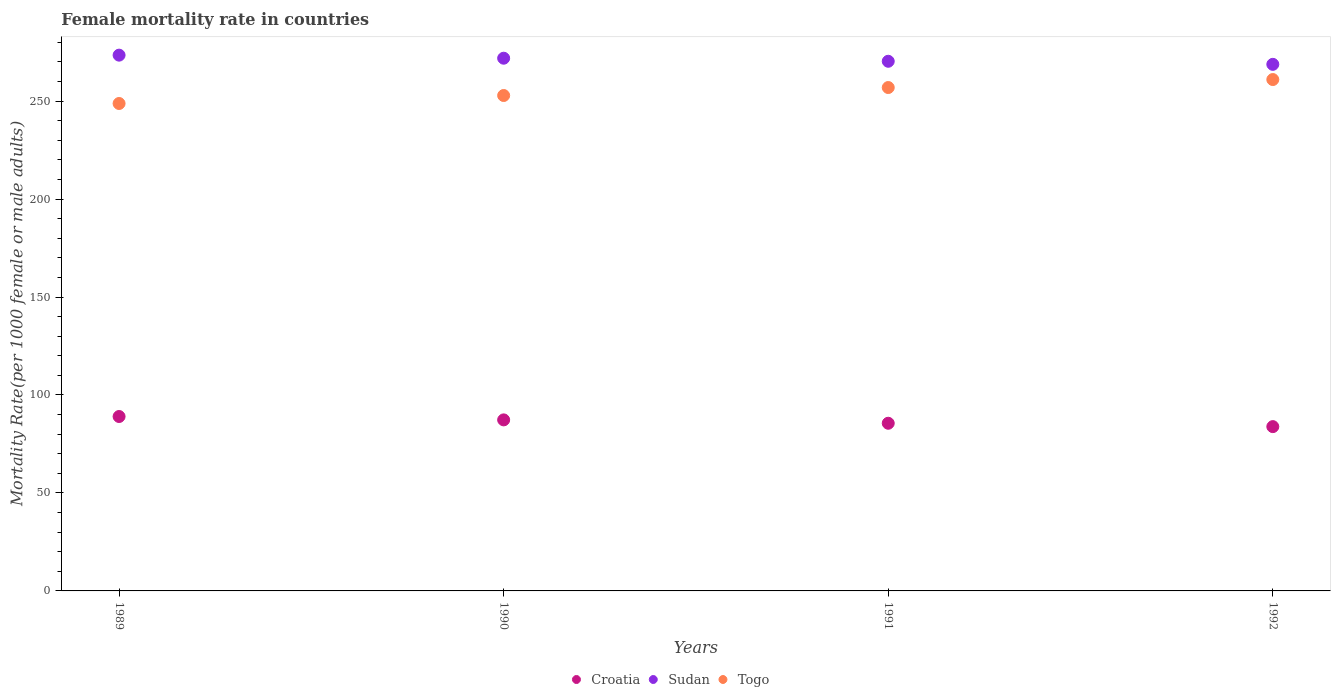How many different coloured dotlines are there?
Provide a short and direct response. 3. Is the number of dotlines equal to the number of legend labels?
Provide a succinct answer. Yes. What is the female mortality rate in Croatia in 1992?
Provide a short and direct response. 83.86. Across all years, what is the maximum female mortality rate in Togo?
Ensure brevity in your answer.  261. Across all years, what is the minimum female mortality rate in Togo?
Make the answer very short. 248.78. In which year was the female mortality rate in Togo maximum?
Your answer should be compact. 1992. In which year was the female mortality rate in Togo minimum?
Give a very brief answer. 1989. What is the total female mortality rate in Togo in the graph?
Make the answer very short. 1019.56. What is the difference between the female mortality rate in Sudan in 1991 and that in 1992?
Keep it short and to the point. 1.56. What is the difference between the female mortality rate in Sudan in 1989 and the female mortality rate in Croatia in 1990?
Provide a succinct answer. 186.16. What is the average female mortality rate in Croatia per year?
Keep it short and to the point. 86.44. In the year 1992, what is the difference between the female mortality rate in Togo and female mortality rate in Sudan?
Provide a short and direct response. -7.76. In how many years, is the female mortality rate in Sudan greater than 150?
Your answer should be very brief. 4. What is the ratio of the female mortality rate in Sudan in 1989 to that in 1992?
Make the answer very short. 1.02. Is the difference between the female mortality rate in Togo in 1991 and 1992 greater than the difference between the female mortality rate in Sudan in 1991 and 1992?
Keep it short and to the point. No. What is the difference between the highest and the second highest female mortality rate in Croatia?
Your answer should be compact. 1.72. What is the difference between the highest and the lowest female mortality rate in Sudan?
Your response must be concise. 4.69. In how many years, is the female mortality rate in Togo greater than the average female mortality rate in Togo taken over all years?
Your answer should be very brief. 2. Does the female mortality rate in Sudan monotonically increase over the years?
Offer a terse response. No. Is the female mortality rate in Togo strictly greater than the female mortality rate in Croatia over the years?
Give a very brief answer. Yes. Is the female mortality rate in Togo strictly less than the female mortality rate in Sudan over the years?
Offer a terse response. Yes. What is the difference between two consecutive major ticks on the Y-axis?
Ensure brevity in your answer.  50. Where does the legend appear in the graph?
Your response must be concise. Bottom center. How many legend labels are there?
Your response must be concise. 3. How are the legend labels stacked?
Your answer should be very brief. Horizontal. What is the title of the graph?
Ensure brevity in your answer.  Female mortality rate in countries. What is the label or title of the X-axis?
Keep it short and to the point. Years. What is the label or title of the Y-axis?
Your response must be concise. Mortality Rate(per 1000 female or male adults). What is the Mortality Rate(per 1000 female or male adults) of Croatia in 1989?
Offer a very short reply. 89.02. What is the Mortality Rate(per 1000 female or male adults) of Sudan in 1989?
Ensure brevity in your answer.  273.45. What is the Mortality Rate(per 1000 female or male adults) in Togo in 1989?
Provide a succinct answer. 248.78. What is the Mortality Rate(per 1000 female or male adults) of Croatia in 1990?
Ensure brevity in your answer.  87.3. What is the Mortality Rate(per 1000 female or male adults) in Sudan in 1990?
Ensure brevity in your answer.  271.89. What is the Mortality Rate(per 1000 female or male adults) of Togo in 1990?
Make the answer very short. 252.85. What is the Mortality Rate(per 1000 female or male adults) in Croatia in 1991?
Your response must be concise. 85.58. What is the Mortality Rate(per 1000 female or male adults) of Sudan in 1991?
Your answer should be very brief. 270.33. What is the Mortality Rate(per 1000 female or male adults) of Togo in 1991?
Provide a short and direct response. 256.93. What is the Mortality Rate(per 1000 female or male adults) in Croatia in 1992?
Provide a short and direct response. 83.86. What is the Mortality Rate(per 1000 female or male adults) of Sudan in 1992?
Ensure brevity in your answer.  268.76. What is the Mortality Rate(per 1000 female or male adults) in Togo in 1992?
Your answer should be very brief. 261. Across all years, what is the maximum Mortality Rate(per 1000 female or male adults) of Croatia?
Offer a terse response. 89.02. Across all years, what is the maximum Mortality Rate(per 1000 female or male adults) in Sudan?
Offer a very short reply. 273.45. Across all years, what is the maximum Mortality Rate(per 1000 female or male adults) of Togo?
Ensure brevity in your answer.  261. Across all years, what is the minimum Mortality Rate(per 1000 female or male adults) of Croatia?
Your response must be concise. 83.86. Across all years, what is the minimum Mortality Rate(per 1000 female or male adults) in Sudan?
Keep it short and to the point. 268.76. Across all years, what is the minimum Mortality Rate(per 1000 female or male adults) of Togo?
Offer a terse response. 248.78. What is the total Mortality Rate(per 1000 female or male adults) of Croatia in the graph?
Offer a very short reply. 345.75. What is the total Mortality Rate(per 1000 female or male adults) in Sudan in the graph?
Give a very brief answer. 1084.44. What is the total Mortality Rate(per 1000 female or male adults) in Togo in the graph?
Provide a short and direct response. 1019.56. What is the difference between the Mortality Rate(per 1000 female or male adults) in Croatia in 1989 and that in 1990?
Your response must be concise. 1.72. What is the difference between the Mortality Rate(per 1000 female or male adults) in Sudan in 1989 and that in 1990?
Ensure brevity in your answer.  1.56. What is the difference between the Mortality Rate(per 1000 female or male adults) of Togo in 1989 and that in 1990?
Ensure brevity in your answer.  -4.07. What is the difference between the Mortality Rate(per 1000 female or male adults) in Croatia in 1989 and that in 1991?
Provide a succinct answer. 3.44. What is the difference between the Mortality Rate(per 1000 female or male adults) in Sudan in 1989 and that in 1991?
Provide a short and direct response. 3.13. What is the difference between the Mortality Rate(per 1000 female or male adults) of Togo in 1989 and that in 1991?
Your answer should be very brief. -8.15. What is the difference between the Mortality Rate(per 1000 female or male adults) in Croatia in 1989 and that in 1992?
Your response must be concise. 5.16. What is the difference between the Mortality Rate(per 1000 female or male adults) in Sudan in 1989 and that in 1992?
Keep it short and to the point. 4.69. What is the difference between the Mortality Rate(per 1000 female or male adults) in Togo in 1989 and that in 1992?
Your response must be concise. -12.22. What is the difference between the Mortality Rate(per 1000 female or male adults) of Croatia in 1990 and that in 1991?
Offer a very short reply. 1.72. What is the difference between the Mortality Rate(per 1000 female or male adults) of Sudan in 1990 and that in 1991?
Provide a short and direct response. 1.56. What is the difference between the Mortality Rate(per 1000 female or male adults) of Togo in 1990 and that in 1991?
Keep it short and to the point. -4.07. What is the difference between the Mortality Rate(per 1000 female or male adults) of Croatia in 1990 and that in 1992?
Your answer should be very brief. 3.44. What is the difference between the Mortality Rate(per 1000 female or male adults) in Sudan in 1990 and that in 1992?
Your answer should be very brief. 3.13. What is the difference between the Mortality Rate(per 1000 female or male adults) in Togo in 1990 and that in 1992?
Provide a succinct answer. -8.15. What is the difference between the Mortality Rate(per 1000 female or male adults) in Croatia in 1991 and that in 1992?
Keep it short and to the point. 1.72. What is the difference between the Mortality Rate(per 1000 female or male adults) in Sudan in 1991 and that in 1992?
Provide a succinct answer. 1.56. What is the difference between the Mortality Rate(per 1000 female or male adults) of Togo in 1991 and that in 1992?
Offer a terse response. -4.07. What is the difference between the Mortality Rate(per 1000 female or male adults) of Croatia in 1989 and the Mortality Rate(per 1000 female or male adults) of Sudan in 1990?
Provide a short and direct response. -182.87. What is the difference between the Mortality Rate(per 1000 female or male adults) of Croatia in 1989 and the Mortality Rate(per 1000 female or male adults) of Togo in 1990?
Provide a short and direct response. -163.84. What is the difference between the Mortality Rate(per 1000 female or male adults) in Sudan in 1989 and the Mortality Rate(per 1000 female or male adults) in Togo in 1990?
Your answer should be very brief. 20.6. What is the difference between the Mortality Rate(per 1000 female or male adults) in Croatia in 1989 and the Mortality Rate(per 1000 female or male adults) in Sudan in 1991?
Give a very brief answer. -181.31. What is the difference between the Mortality Rate(per 1000 female or male adults) of Croatia in 1989 and the Mortality Rate(per 1000 female or male adults) of Togo in 1991?
Make the answer very short. -167.91. What is the difference between the Mortality Rate(per 1000 female or male adults) in Sudan in 1989 and the Mortality Rate(per 1000 female or male adults) in Togo in 1991?
Ensure brevity in your answer.  16.53. What is the difference between the Mortality Rate(per 1000 female or male adults) in Croatia in 1989 and the Mortality Rate(per 1000 female or male adults) in Sudan in 1992?
Your answer should be very brief. -179.74. What is the difference between the Mortality Rate(per 1000 female or male adults) of Croatia in 1989 and the Mortality Rate(per 1000 female or male adults) of Togo in 1992?
Offer a terse response. -171.98. What is the difference between the Mortality Rate(per 1000 female or male adults) in Sudan in 1989 and the Mortality Rate(per 1000 female or male adults) in Togo in 1992?
Keep it short and to the point. 12.45. What is the difference between the Mortality Rate(per 1000 female or male adults) in Croatia in 1990 and the Mortality Rate(per 1000 female or male adults) in Sudan in 1991?
Ensure brevity in your answer.  -183.03. What is the difference between the Mortality Rate(per 1000 female or male adults) in Croatia in 1990 and the Mortality Rate(per 1000 female or male adults) in Togo in 1991?
Provide a short and direct response. -169.63. What is the difference between the Mortality Rate(per 1000 female or male adults) of Sudan in 1990 and the Mortality Rate(per 1000 female or male adults) of Togo in 1991?
Your response must be concise. 14.96. What is the difference between the Mortality Rate(per 1000 female or male adults) in Croatia in 1990 and the Mortality Rate(per 1000 female or male adults) in Sudan in 1992?
Your answer should be very brief. -181.47. What is the difference between the Mortality Rate(per 1000 female or male adults) in Croatia in 1990 and the Mortality Rate(per 1000 female or male adults) in Togo in 1992?
Provide a succinct answer. -173.7. What is the difference between the Mortality Rate(per 1000 female or male adults) of Sudan in 1990 and the Mortality Rate(per 1000 female or male adults) of Togo in 1992?
Offer a terse response. 10.89. What is the difference between the Mortality Rate(per 1000 female or male adults) of Croatia in 1991 and the Mortality Rate(per 1000 female or male adults) of Sudan in 1992?
Ensure brevity in your answer.  -183.19. What is the difference between the Mortality Rate(per 1000 female or male adults) in Croatia in 1991 and the Mortality Rate(per 1000 female or male adults) in Togo in 1992?
Ensure brevity in your answer.  -175.42. What is the difference between the Mortality Rate(per 1000 female or male adults) of Sudan in 1991 and the Mortality Rate(per 1000 female or male adults) of Togo in 1992?
Your response must be concise. 9.33. What is the average Mortality Rate(per 1000 female or male adults) in Croatia per year?
Provide a short and direct response. 86.44. What is the average Mortality Rate(per 1000 female or male adults) in Sudan per year?
Provide a succinct answer. 271.11. What is the average Mortality Rate(per 1000 female or male adults) of Togo per year?
Your answer should be compact. 254.89. In the year 1989, what is the difference between the Mortality Rate(per 1000 female or male adults) in Croatia and Mortality Rate(per 1000 female or male adults) in Sudan?
Ensure brevity in your answer.  -184.44. In the year 1989, what is the difference between the Mortality Rate(per 1000 female or male adults) in Croatia and Mortality Rate(per 1000 female or male adults) in Togo?
Your answer should be compact. -159.76. In the year 1989, what is the difference between the Mortality Rate(per 1000 female or male adults) of Sudan and Mortality Rate(per 1000 female or male adults) of Togo?
Ensure brevity in your answer.  24.68. In the year 1990, what is the difference between the Mortality Rate(per 1000 female or male adults) of Croatia and Mortality Rate(per 1000 female or male adults) of Sudan?
Provide a succinct answer. -184.59. In the year 1990, what is the difference between the Mortality Rate(per 1000 female or male adults) in Croatia and Mortality Rate(per 1000 female or male adults) in Togo?
Your answer should be compact. -165.56. In the year 1990, what is the difference between the Mortality Rate(per 1000 female or male adults) in Sudan and Mortality Rate(per 1000 female or male adults) in Togo?
Provide a succinct answer. 19.04. In the year 1991, what is the difference between the Mortality Rate(per 1000 female or male adults) in Croatia and Mortality Rate(per 1000 female or male adults) in Sudan?
Offer a terse response. -184.75. In the year 1991, what is the difference between the Mortality Rate(per 1000 female or male adults) in Croatia and Mortality Rate(per 1000 female or male adults) in Togo?
Keep it short and to the point. -171.35. In the year 1992, what is the difference between the Mortality Rate(per 1000 female or male adults) of Croatia and Mortality Rate(per 1000 female or male adults) of Sudan?
Give a very brief answer. -184.91. In the year 1992, what is the difference between the Mortality Rate(per 1000 female or male adults) in Croatia and Mortality Rate(per 1000 female or male adults) in Togo?
Your answer should be very brief. -177.15. In the year 1992, what is the difference between the Mortality Rate(per 1000 female or male adults) of Sudan and Mortality Rate(per 1000 female or male adults) of Togo?
Offer a very short reply. 7.76. What is the ratio of the Mortality Rate(per 1000 female or male adults) in Croatia in 1989 to that in 1990?
Offer a terse response. 1.02. What is the ratio of the Mortality Rate(per 1000 female or male adults) of Togo in 1989 to that in 1990?
Your answer should be compact. 0.98. What is the ratio of the Mortality Rate(per 1000 female or male adults) of Croatia in 1989 to that in 1991?
Your answer should be compact. 1.04. What is the ratio of the Mortality Rate(per 1000 female or male adults) in Sudan in 1989 to that in 1991?
Give a very brief answer. 1.01. What is the ratio of the Mortality Rate(per 1000 female or male adults) in Togo in 1989 to that in 1991?
Offer a very short reply. 0.97. What is the ratio of the Mortality Rate(per 1000 female or male adults) of Croatia in 1989 to that in 1992?
Your answer should be compact. 1.06. What is the ratio of the Mortality Rate(per 1000 female or male adults) of Sudan in 1989 to that in 1992?
Your answer should be compact. 1.02. What is the ratio of the Mortality Rate(per 1000 female or male adults) of Togo in 1989 to that in 1992?
Your response must be concise. 0.95. What is the ratio of the Mortality Rate(per 1000 female or male adults) in Croatia in 1990 to that in 1991?
Keep it short and to the point. 1.02. What is the ratio of the Mortality Rate(per 1000 female or male adults) in Togo in 1990 to that in 1991?
Your answer should be very brief. 0.98. What is the ratio of the Mortality Rate(per 1000 female or male adults) in Croatia in 1990 to that in 1992?
Offer a terse response. 1.04. What is the ratio of the Mortality Rate(per 1000 female or male adults) of Sudan in 1990 to that in 1992?
Offer a very short reply. 1.01. What is the ratio of the Mortality Rate(per 1000 female or male adults) of Togo in 1990 to that in 1992?
Your answer should be very brief. 0.97. What is the ratio of the Mortality Rate(per 1000 female or male adults) of Croatia in 1991 to that in 1992?
Provide a short and direct response. 1.02. What is the ratio of the Mortality Rate(per 1000 female or male adults) of Sudan in 1991 to that in 1992?
Make the answer very short. 1.01. What is the ratio of the Mortality Rate(per 1000 female or male adults) of Togo in 1991 to that in 1992?
Give a very brief answer. 0.98. What is the difference between the highest and the second highest Mortality Rate(per 1000 female or male adults) of Croatia?
Offer a terse response. 1.72. What is the difference between the highest and the second highest Mortality Rate(per 1000 female or male adults) in Sudan?
Offer a very short reply. 1.56. What is the difference between the highest and the second highest Mortality Rate(per 1000 female or male adults) in Togo?
Ensure brevity in your answer.  4.07. What is the difference between the highest and the lowest Mortality Rate(per 1000 female or male adults) of Croatia?
Offer a terse response. 5.16. What is the difference between the highest and the lowest Mortality Rate(per 1000 female or male adults) in Sudan?
Your answer should be compact. 4.69. What is the difference between the highest and the lowest Mortality Rate(per 1000 female or male adults) in Togo?
Offer a very short reply. 12.22. 